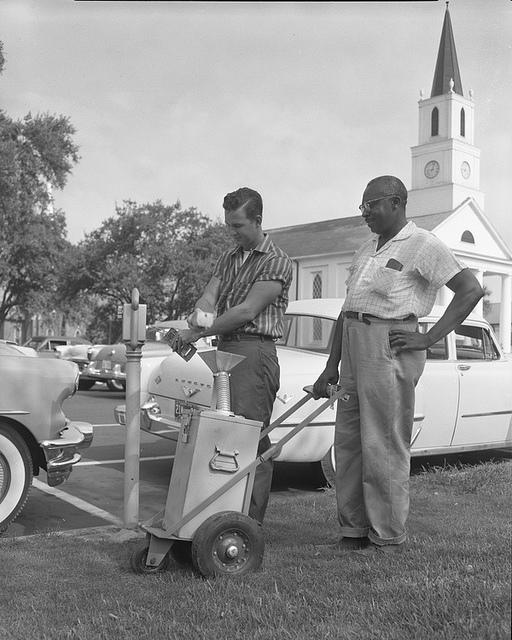What is the couple doing?
Short answer required. Standing. What is the type of material used for the crafts?
Give a very brief answer. Metal. Is there a beach in this scene?
Short answer required. No. Is the picture in color?
Keep it brief. No. Is the man on the right wearing glasses?
Keep it brief. Yes. What are they doing?
Answer briefly. Emptying parking meters. 